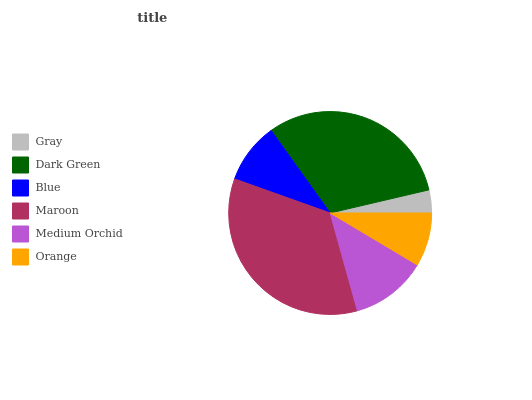Is Gray the minimum?
Answer yes or no. Yes. Is Maroon the maximum?
Answer yes or no. Yes. Is Dark Green the minimum?
Answer yes or no. No. Is Dark Green the maximum?
Answer yes or no. No. Is Dark Green greater than Gray?
Answer yes or no. Yes. Is Gray less than Dark Green?
Answer yes or no. Yes. Is Gray greater than Dark Green?
Answer yes or no. No. Is Dark Green less than Gray?
Answer yes or no. No. Is Medium Orchid the high median?
Answer yes or no. Yes. Is Blue the low median?
Answer yes or no. Yes. Is Orange the high median?
Answer yes or no. No. Is Maroon the low median?
Answer yes or no. No. 